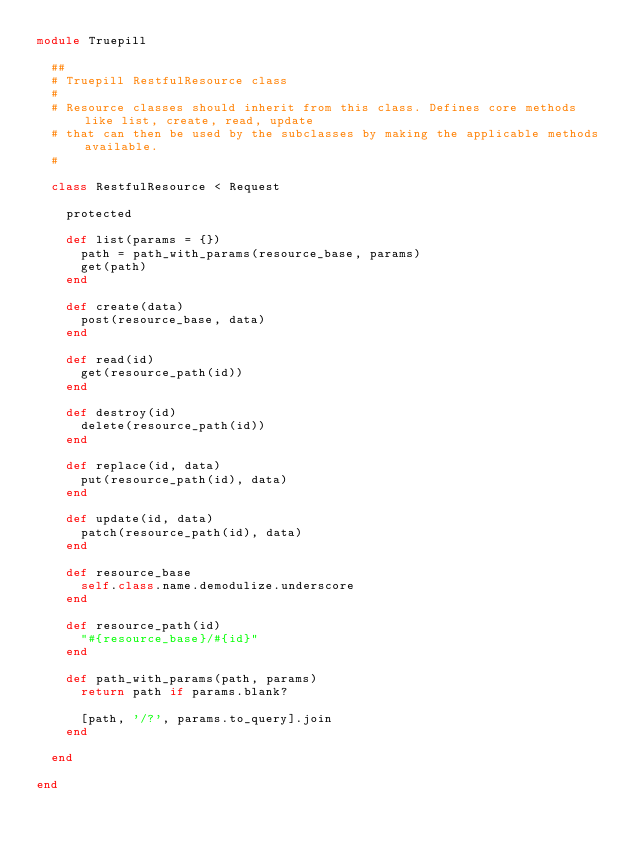Convert code to text. <code><loc_0><loc_0><loc_500><loc_500><_Ruby_>module Truepill

  ##
  # Truepill RestfulResource class
  #
  # Resource classes should inherit from this class. Defines core methods like list, create, read, update
  # that can then be used by the subclasses by making the applicable methods available.
  #

  class RestfulResource < Request

    protected

    def list(params = {})
      path = path_with_params(resource_base, params)
      get(path)
    end

    def create(data)
      post(resource_base, data)
    end

    def read(id)
      get(resource_path(id))
    end

    def destroy(id)
      delete(resource_path(id))
    end

    def replace(id, data)
      put(resource_path(id), data)
    end

    def update(id, data)
      patch(resource_path(id), data)
    end

    def resource_base
      self.class.name.demodulize.underscore
    end

    def resource_path(id)
      "#{resource_base}/#{id}"
    end

    def path_with_params(path, params)
      return path if params.blank?

      [path, '/?', params.to_query].join
    end

  end

end
</code> 